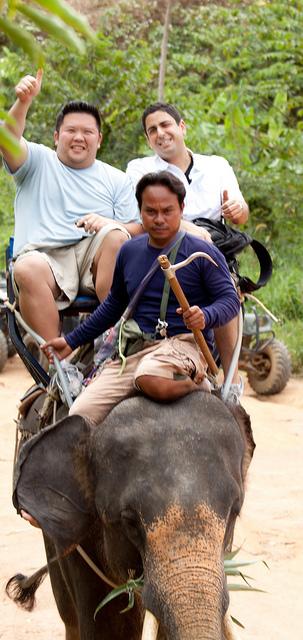How many people are on the elephant?
Give a very brief answer. 3. Is the scene set in South America?
Give a very brief answer. No. What are these people riding?
Write a very short answer. Elephant. 